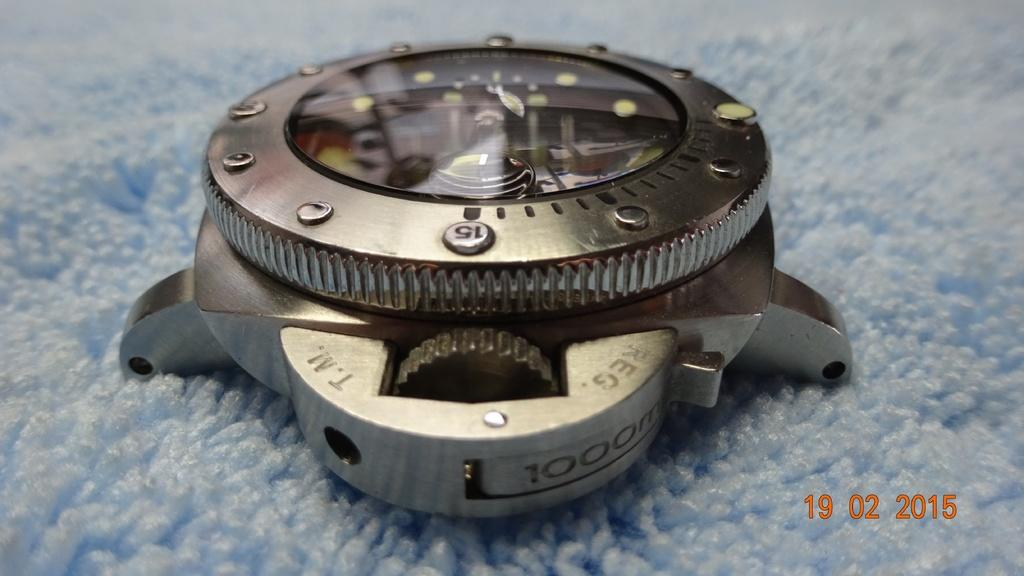<image>
Write a terse but informative summary of the picture. a technical looking instrument with a date of 19 02 2015 on the bottom right 